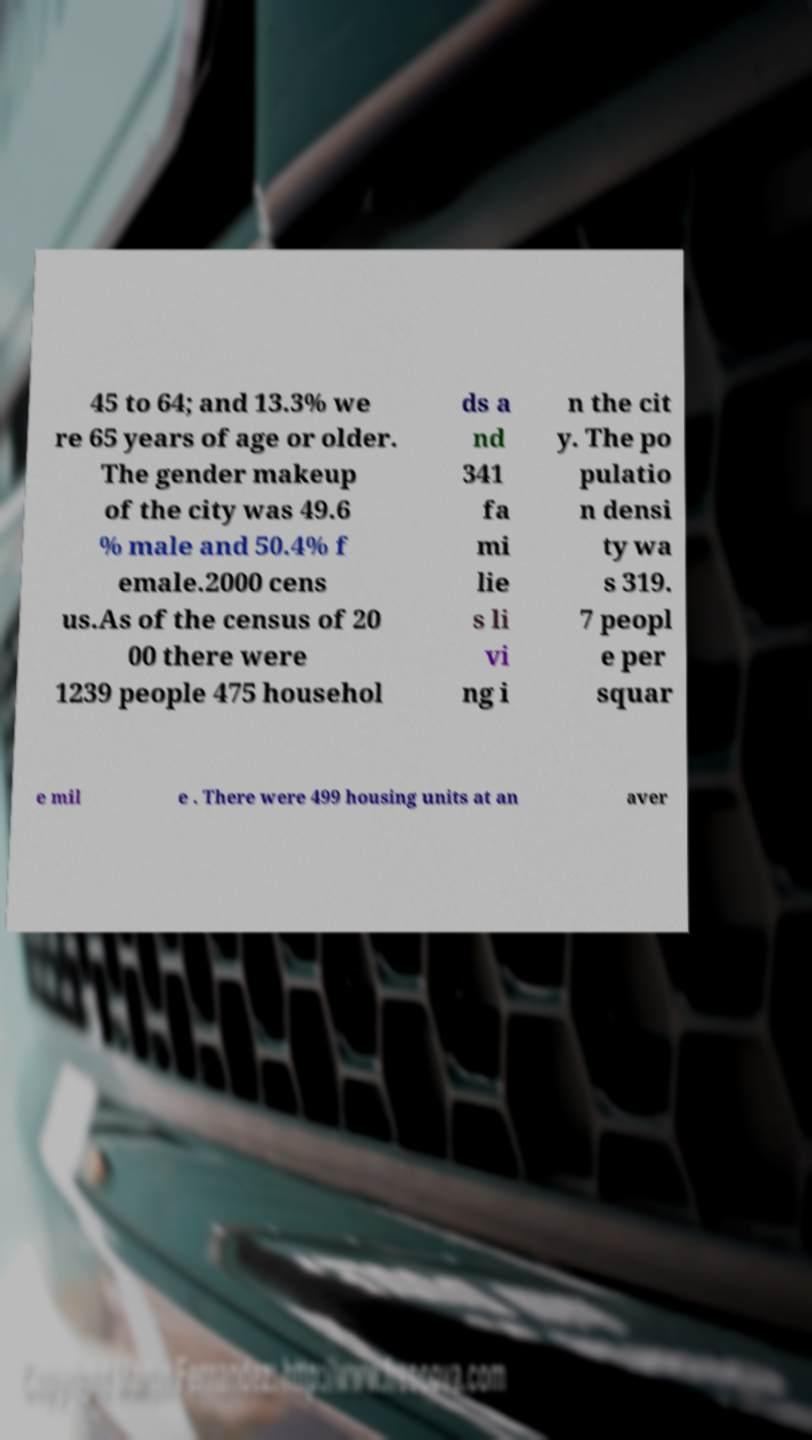Can you read and provide the text displayed in the image?This photo seems to have some interesting text. Can you extract and type it out for me? 45 to 64; and 13.3% we re 65 years of age or older. The gender makeup of the city was 49.6 % male and 50.4% f emale.2000 cens us.As of the census of 20 00 there were 1239 people 475 househol ds a nd 341 fa mi lie s li vi ng i n the cit y. The po pulatio n densi ty wa s 319. 7 peopl e per squar e mil e . There were 499 housing units at an aver 